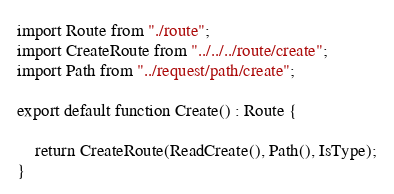<code> <loc_0><loc_0><loc_500><loc_500><_TypeScript_>import Route from "./route";
import CreateRoute from "../../../route/create";
import Path from "../request/path/create";

export default function Create() : Route {

    return CreateRoute(ReadCreate(), Path(), IsType);
}
</code> 